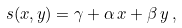<formula> <loc_0><loc_0><loc_500><loc_500>s ( x , y ) = \gamma + \alpha \, x + \beta \, y \, ,</formula> 